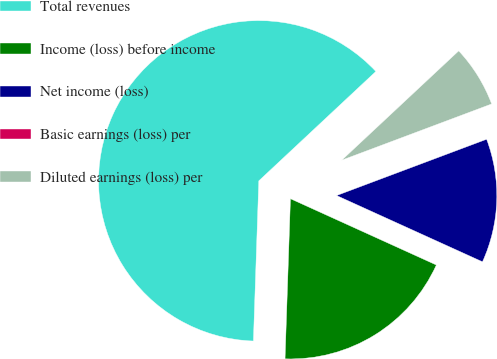<chart> <loc_0><loc_0><loc_500><loc_500><pie_chart><fcel>Total revenues<fcel>Income (loss) before income<fcel>Net income (loss)<fcel>Basic earnings (loss) per<fcel>Diluted earnings (loss) per<nl><fcel>62.5%<fcel>18.75%<fcel>12.5%<fcel>0.0%<fcel>6.25%<nl></chart> 